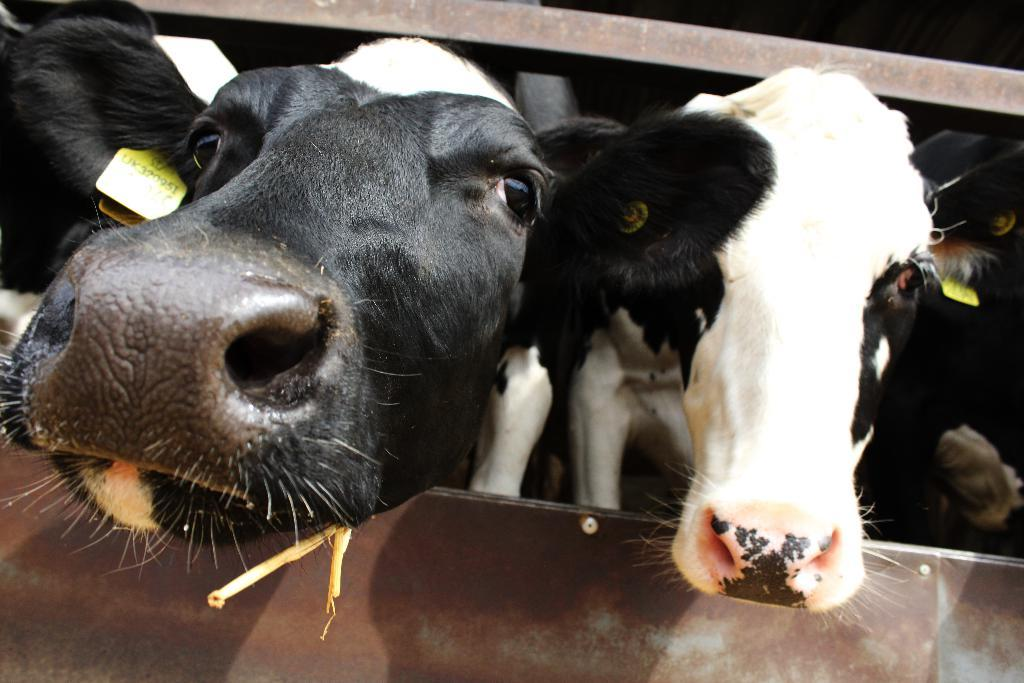What type of animals are depicted in the image? The image contains cow faces. What additional feature can be seen on the cow faces? The cow faces have tags. What type of celery is being used to create the cow faces in the image? There is no celery present in the image; the cow faces are depicted using other materials or methods. 